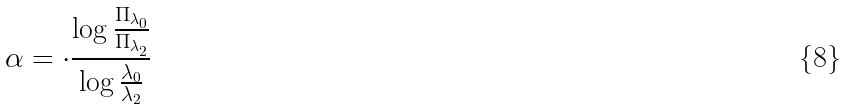Convert formula to latex. <formula><loc_0><loc_0><loc_500><loc_500>\alpha = \cdot \frac { \log \frac { \Pi _ { \lambda _ { 0 } } } { \Pi _ { \lambda _ { 2 } } } } { \log \frac { \lambda _ { 0 } } { \lambda _ { 2 } } }</formula> 